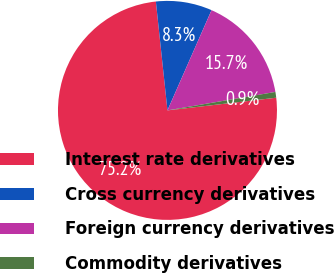<chart> <loc_0><loc_0><loc_500><loc_500><pie_chart><fcel>Interest rate derivatives<fcel>Cross currency derivatives<fcel>Foreign currency derivatives<fcel>Commodity derivatives<nl><fcel>75.15%<fcel>8.28%<fcel>15.71%<fcel>0.85%<nl></chart> 